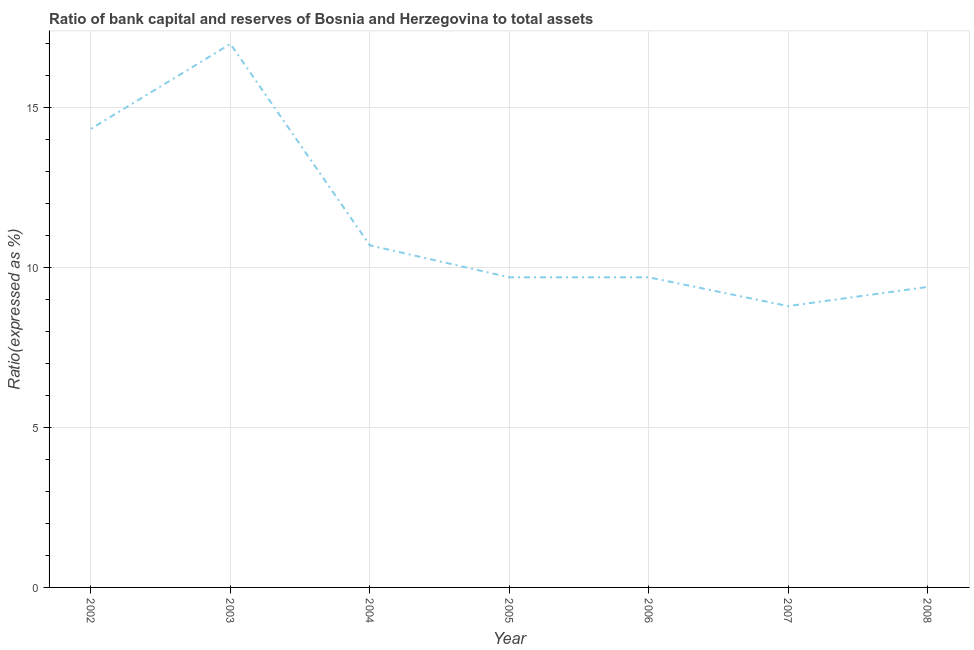What is the bank capital to assets ratio in 2005?
Your answer should be very brief. 9.7. Across all years, what is the minimum bank capital to assets ratio?
Provide a short and direct response. 8.8. What is the sum of the bank capital to assets ratio?
Your answer should be compact. 79.65. What is the difference between the bank capital to assets ratio in 2005 and 2007?
Provide a short and direct response. 0.9. What is the average bank capital to assets ratio per year?
Offer a very short reply. 11.38. In how many years, is the bank capital to assets ratio greater than 4 %?
Offer a very short reply. 7. Do a majority of the years between 2005 and 2007 (inclusive) have bank capital to assets ratio greater than 12 %?
Provide a succinct answer. No. What is the ratio of the bank capital to assets ratio in 2005 to that in 2007?
Your response must be concise. 1.1. Is the difference between the bank capital to assets ratio in 2002 and 2007 greater than the difference between any two years?
Give a very brief answer. No. What is the difference between the highest and the second highest bank capital to assets ratio?
Your response must be concise. 2.65. Is the sum of the bank capital to assets ratio in 2004 and 2006 greater than the maximum bank capital to assets ratio across all years?
Offer a terse response. Yes. In how many years, is the bank capital to assets ratio greater than the average bank capital to assets ratio taken over all years?
Offer a very short reply. 2. What is the difference between two consecutive major ticks on the Y-axis?
Provide a succinct answer. 5. Does the graph contain any zero values?
Your answer should be very brief. No. Does the graph contain grids?
Your answer should be very brief. Yes. What is the title of the graph?
Keep it short and to the point. Ratio of bank capital and reserves of Bosnia and Herzegovina to total assets. What is the label or title of the Y-axis?
Ensure brevity in your answer.  Ratio(expressed as %). What is the Ratio(expressed as %) in 2002?
Provide a succinct answer. 14.35. What is the Ratio(expressed as %) of 2005?
Ensure brevity in your answer.  9.7. What is the Ratio(expressed as %) in 2008?
Ensure brevity in your answer.  9.4. What is the difference between the Ratio(expressed as %) in 2002 and 2003?
Offer a terse response. -2.65. What is the difference between the Ratio(expressed as %) in 2002 and 2004?
Make the answer very short. 3.65. What is the difference between the Ratio(expressed as %) in 2002 and 2005?
Your response must be concise. 4.65. What is the difference between the Ratio(expressed as %) in 2002 and 2006?
Your response must be concise. 4.65. What is the difference between the Ratio(expressed as %) in 2002 and 2007?
Offer a terse response. 5.55. What is the difference between the Ratio(expressed as %) in 2002 and 2008?
Your answer should be very brief. 4.95. What is the difference between the Ratio(expressed as %) in 2003 and 2004?
Your answer should be compact. 6.3. What is the difference between the Ratio(expressed as %) in 2003 and 2005?
Provide a succinct answer. 7.3. What is the difference between the Ratio(expressed as %) in 2003 and 2008?
Make the answer very short. 7.6. What is the difference between the Ratio(expressed as %) in 2004 and 2006?
Provide a succinct answer. 1. What is the difference between the Ratio(expressed as %) in 2004 and 2007?
Your answer should be compact. 1.9. What is the difference between the Ratio(expressed as %) in 2004 and 2008?
Provide a succinct answer. 1.3. What is the difference between the Ratio(expressed as %) in 2005 and 2006?
Offer a terse response. 0. What is the difference between the Ratio(expressed as %) in 2005 and 2007?
Make the answer very short. 0.9. What is the difference between the Ratio(expressed as %) in 2005 and 2008?
Your answer should be compact. 0.3. What is the ratio of the Ratio(expressed as %) in 2002 to that in 2003?
Provide a short and direct response. 0.84. What is the ratio of the Ratio(expressed as %) in 2002 to that in 2004?
Your response must be concise. 1.34. What is the ratio of the Ratio(expressed as %) in 2002 to that in 2005?
Keep it short and to the point. 1.48. What is the ratio of the Ratio(expressed as %) in 2002 to that in 2006?
Offer a terse response. 1.48. What is the ratio of the Ratio(expressed as %) in 2002 to that in 2007?
Offer a very short reply. 1.63. What is the ratio of the Ratio(expressed as %) in 2002 to that in 2008?
Make the answer very short. 1.53. What is the ratio of the Ratio(expressed as %) in 2003 to that in 2004?
Make the answer very short. 1.59. What is the ratio of the Ratio(expressed as %) in 2003 to that in 2005?
Give a very brief answer. 1.75. What is the ratio of the Ratio(expressed as %) in 2003 to that in 2006?
Your answer should be very brief. 1.75. What is the ratio of the Ratio(expressed as %) in 2003 to that in 2007?
Provide a succinct answer. 1.93. What is the ratio of the Ratio(expressed as %) in 2003 to that in 2008?
Provide a succinct answer. 1.81. What is the ratio of the Ratio(expressed as %) in 2004 to that in 2005?
Provide a short and direct response. 1.1. What is the ratio of the Ratio(expressed as %) in 2004 to that in 2006?
Offer a terse response. 1.1. What is the ratio of the Ratio(expressed as %) in 2004 to that in 2007?
Your answer should be very brief. 1.22. What is the ratio of the Ratio(expressed as %) in 2004 to that in 2008?
Give a very brief answer. 1.14. What is the ratio of the Ratio(expressed as %) in 2005 to that in 2007?
Provide a succinct answer. 1.1. What is the ratio of the Ratio(expressed as %) in 2005 to that in 2008?
Keep it short and to the point. 1.03. What is the ratio of the Ratio(expressed as %) in 2006 to that in 2007?
Ensure brevity in your answer.  1.1. What is the ratio of the Ratio(expressed as %) in 2006 to that in 2008?
Your response must be concise. 1.03. What is the ratio of the Ratio(expressed as %) in 2007 to that in 2008?
Offer a terse response. 0.94. 